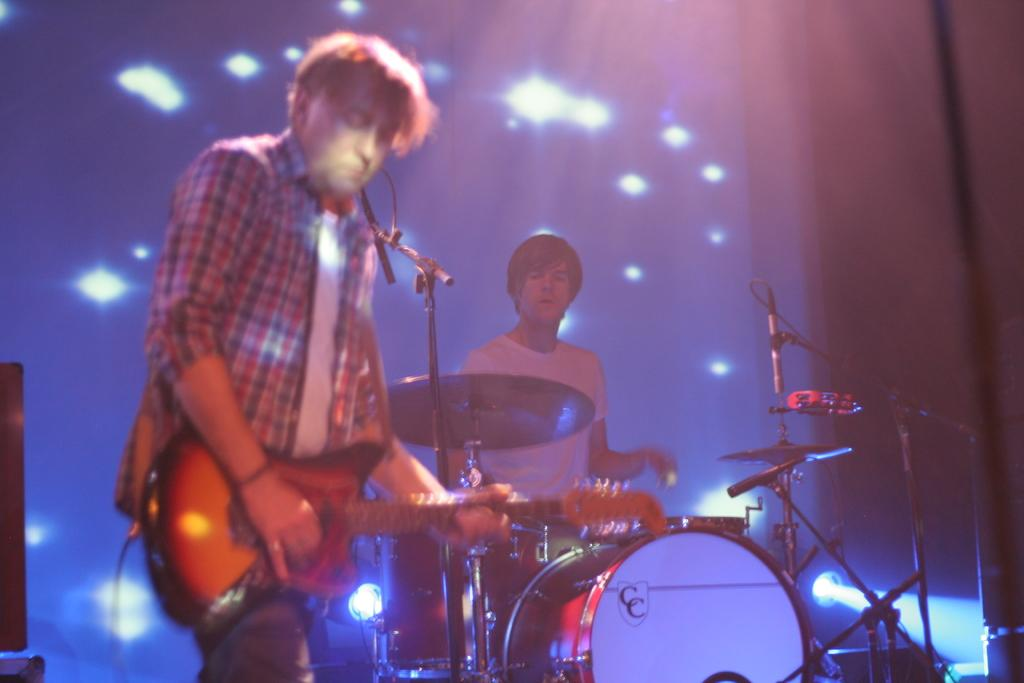How many people are in the image? There are two men in the image. What are the men doing in the image? Both men are playing musical instruments. Can you describe the instruments each man is playing? One man is playing the guitar, and the other man is beating the drums. What can be seen in the background of the image? There is a curtain in the background of the image. Are there any additional features on the curtain? Yes, there are flash lights on the curtain. What type of doctor is standing next to the family in the image? There is no doctor or family present in the image; it features two men playing musical instruments. Can you tell me how many strangers are visible in the image? There are no strangers visible in the image; only the two men playing musical instruments are present. 